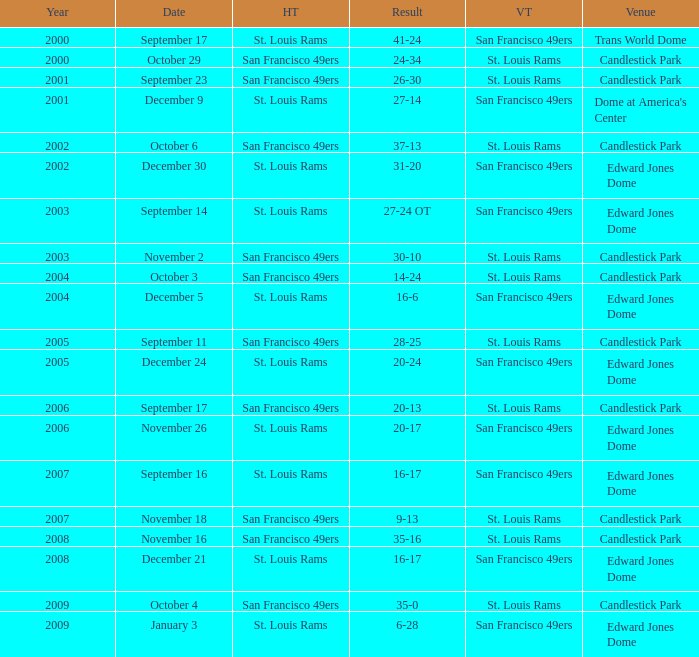What Date after 2007 had the San Francisco 49ers as the Visiting Team? December 21, January 3. 